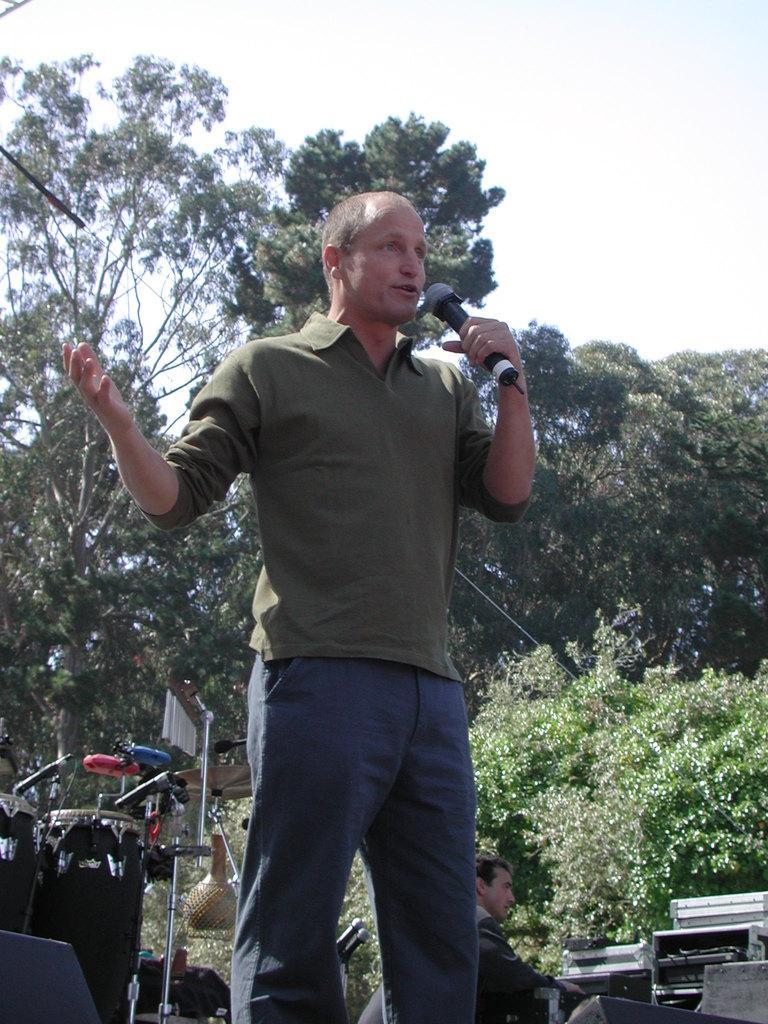Please provide a concise description of this image. As we can see in the image there is a sky, trees and a man holding mic. 